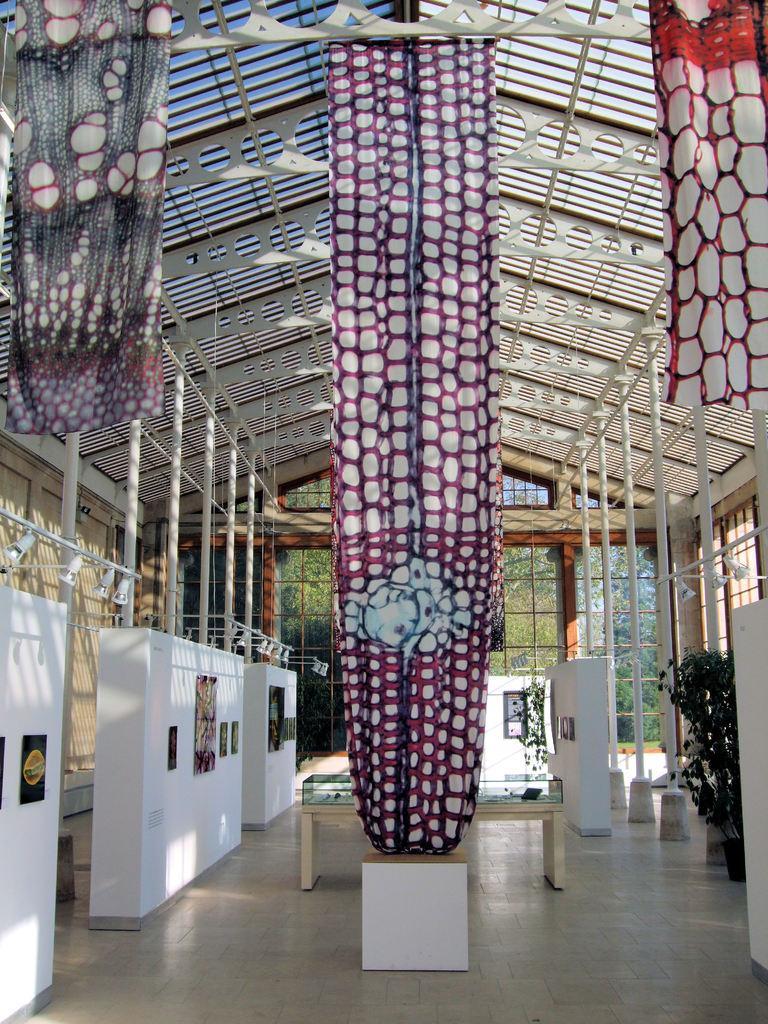Can you describe this image briefly? In this image I can see few colorful curtains. I can see a table,poles,lights,frames,trees,flower pot,glass windows and shed. 